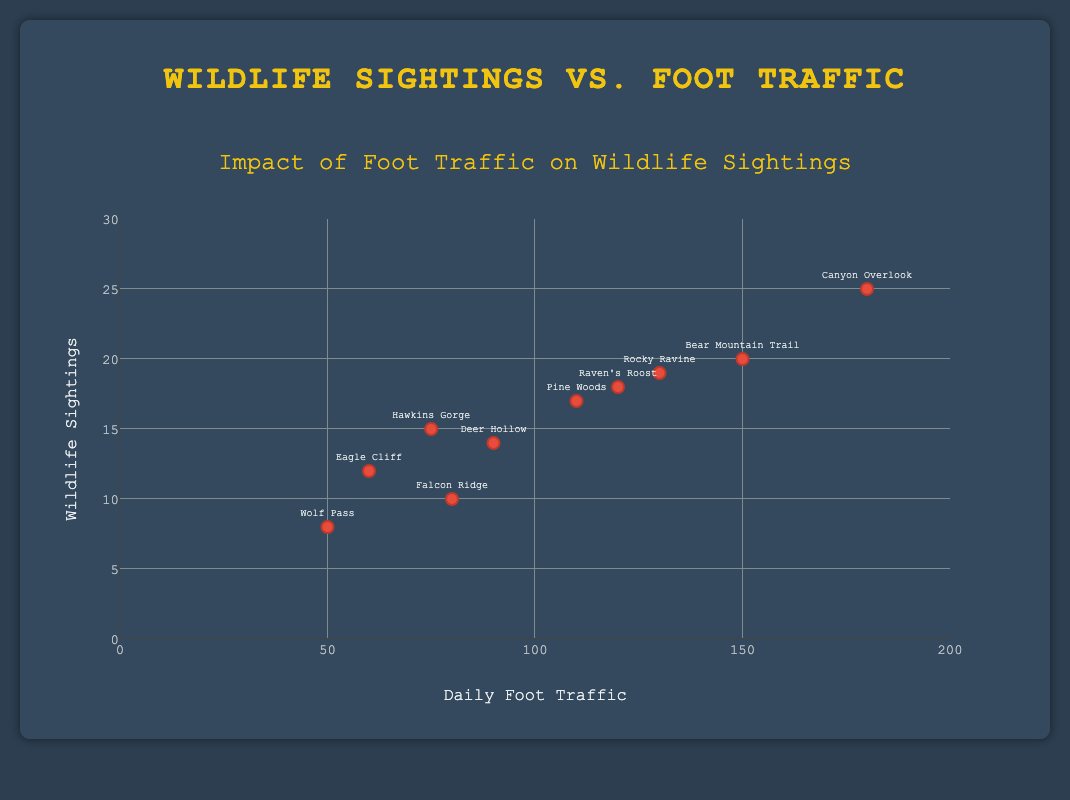which location has the highest daily foot traffic? From the figure, check the data point on the x-axis. "Canyon Overlook" has the highest foot traffic of 180.
Answer: Canyon Overlook what is the range of wildlife sightings? From the figure, look at the y-axis values. The range is from the minimum value (8 at Wolf Pass) to the maximum value (25 at Canyon Overlook).
Answer: 8 to 25 how does daily foot traffic affect wildlife sightings, according to the trend line? The trend line shows a positive slope, indicating that as daily foot traffic increases, wildlife sightings also increase.
Answer: Positive correlation which location has the lowest number of wildlife sightings? From the figure, check the data points on the y-axis. "Wolf Pass" has the lowest number of wildlife sightings with 8.
Answer: Wolf Pass how many locations have a foot traffic count greater than 100? From the figure, count the data points that exceed 100 on the x-axis. The locations are Bear Mountain Trail, Raven's Roost, Canyon Overlook, Pine Woods, and Rocky Ravine, making a total of 5.
Answer: 5 compare the wildlife sightings between eagle cliff and falcon ridge. Which location has more sightings? Eagle Cliff has 12 wildlife sightings, while Falcon Ridge has 10 wildlife sightings. Therefore, Eagle Cliff has more sightings than Falcon Ridge.
Answer: Eagle Cliff if you order the locations by decreasing foot traffic, which location comes third? From the figure, "Raven's Roost" has the third highest foot traffic with a count of 120, following Canyon Overlook (180) and Bear Mountain Trail (150).
Answer: Raven's Roost what is the median value of daily foot traffic across all locations? Order the foot traffic values: 50, 60, 75, 80, 90, 110, 120, 130, 150, 180. The median value is the average of the 5th and 6th values: (90 + 110) / 2 = 100.
Answer: 100 